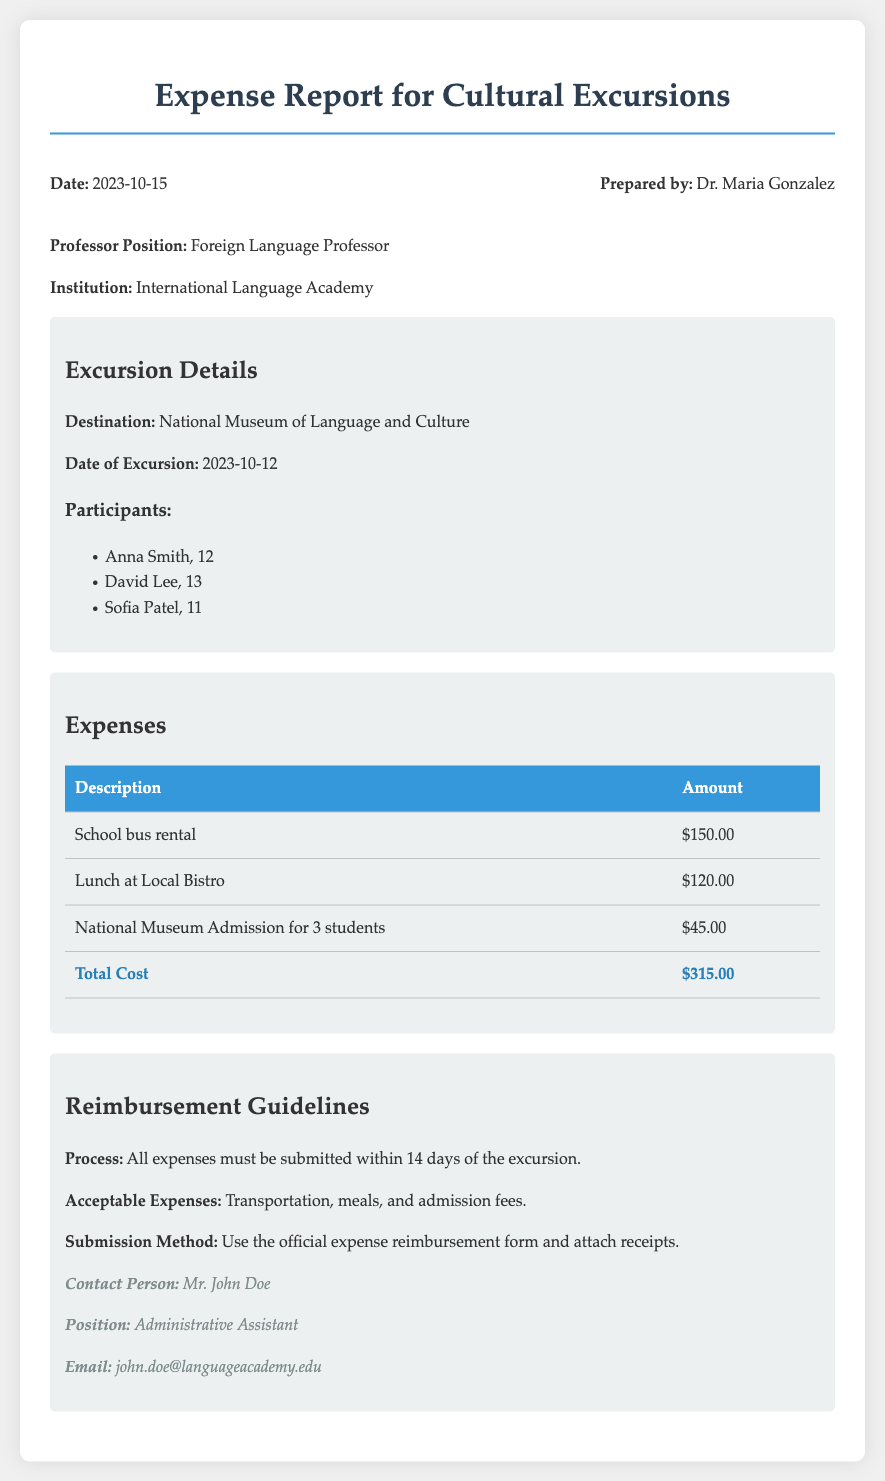What is the total cost of the excursion? The total cost is found in the expenses section of the document, summing up all listed expenses: $150.00 + $120.00 + $45.00 = $315.00.
Answer: $315.00 Who prepared the expense report? The preparer's name is listed at the top of the document under "Prepared by."
Answer: Dr. Maria Gonzalez What date was the excursion held? The date of the excursion is specified in the excursion details section.
Answer: 2023-10-12 How many students participated in the excursion? The number of students is listed in the excursion details section under participants.
Answer: 3 What is the submission method for reimbursement? The submission method is detailed in the reimbursement guidelines, stating to use the official form and attach receipts.
Answer: Official expense reimbursement form and attach receipts What types of expenses are acceptable for reimbursement? Acceptable expenses are listed under reimbursement guidelines.
Answer: Transportation, meals, and admission fees What is the contact person's email? The email of the contact person is found in the contact info section at the bottom of the document.
Answer: john.doe@languageacademy.edu What is the maximum allowed time to submit expenses? The document specifies the submission timeframe in the reimbursement guidelines.
Answer: 14 days 